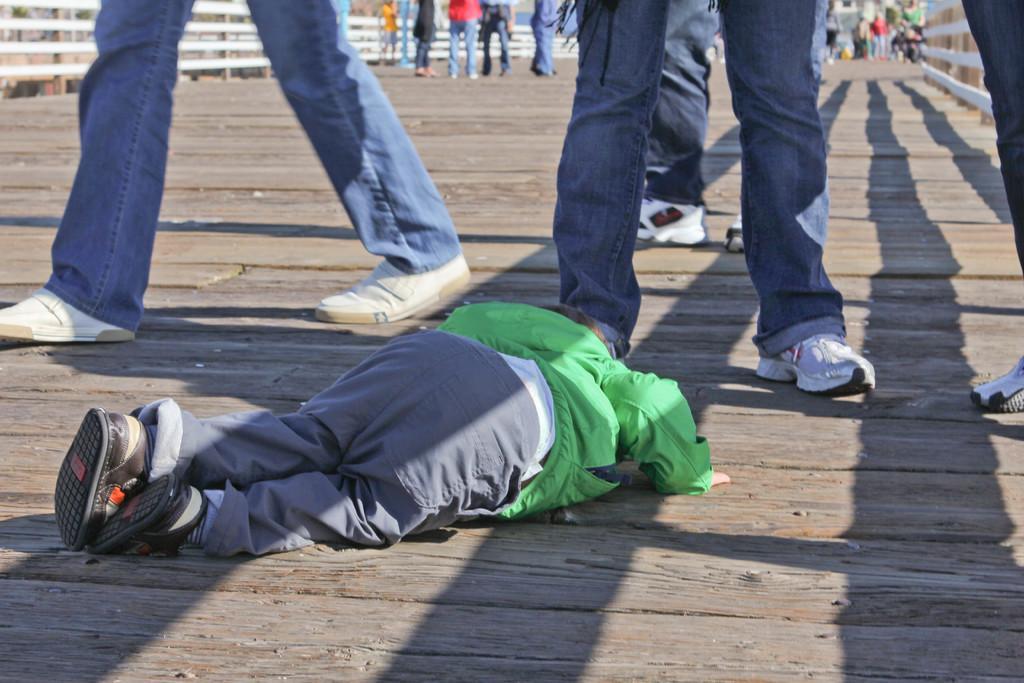Describe this image in one or two sentences. In this image I can see the wooden floor and a person lying on the wooden floor. I can see number of persons are standing, the white colored railing and a building in the background. 